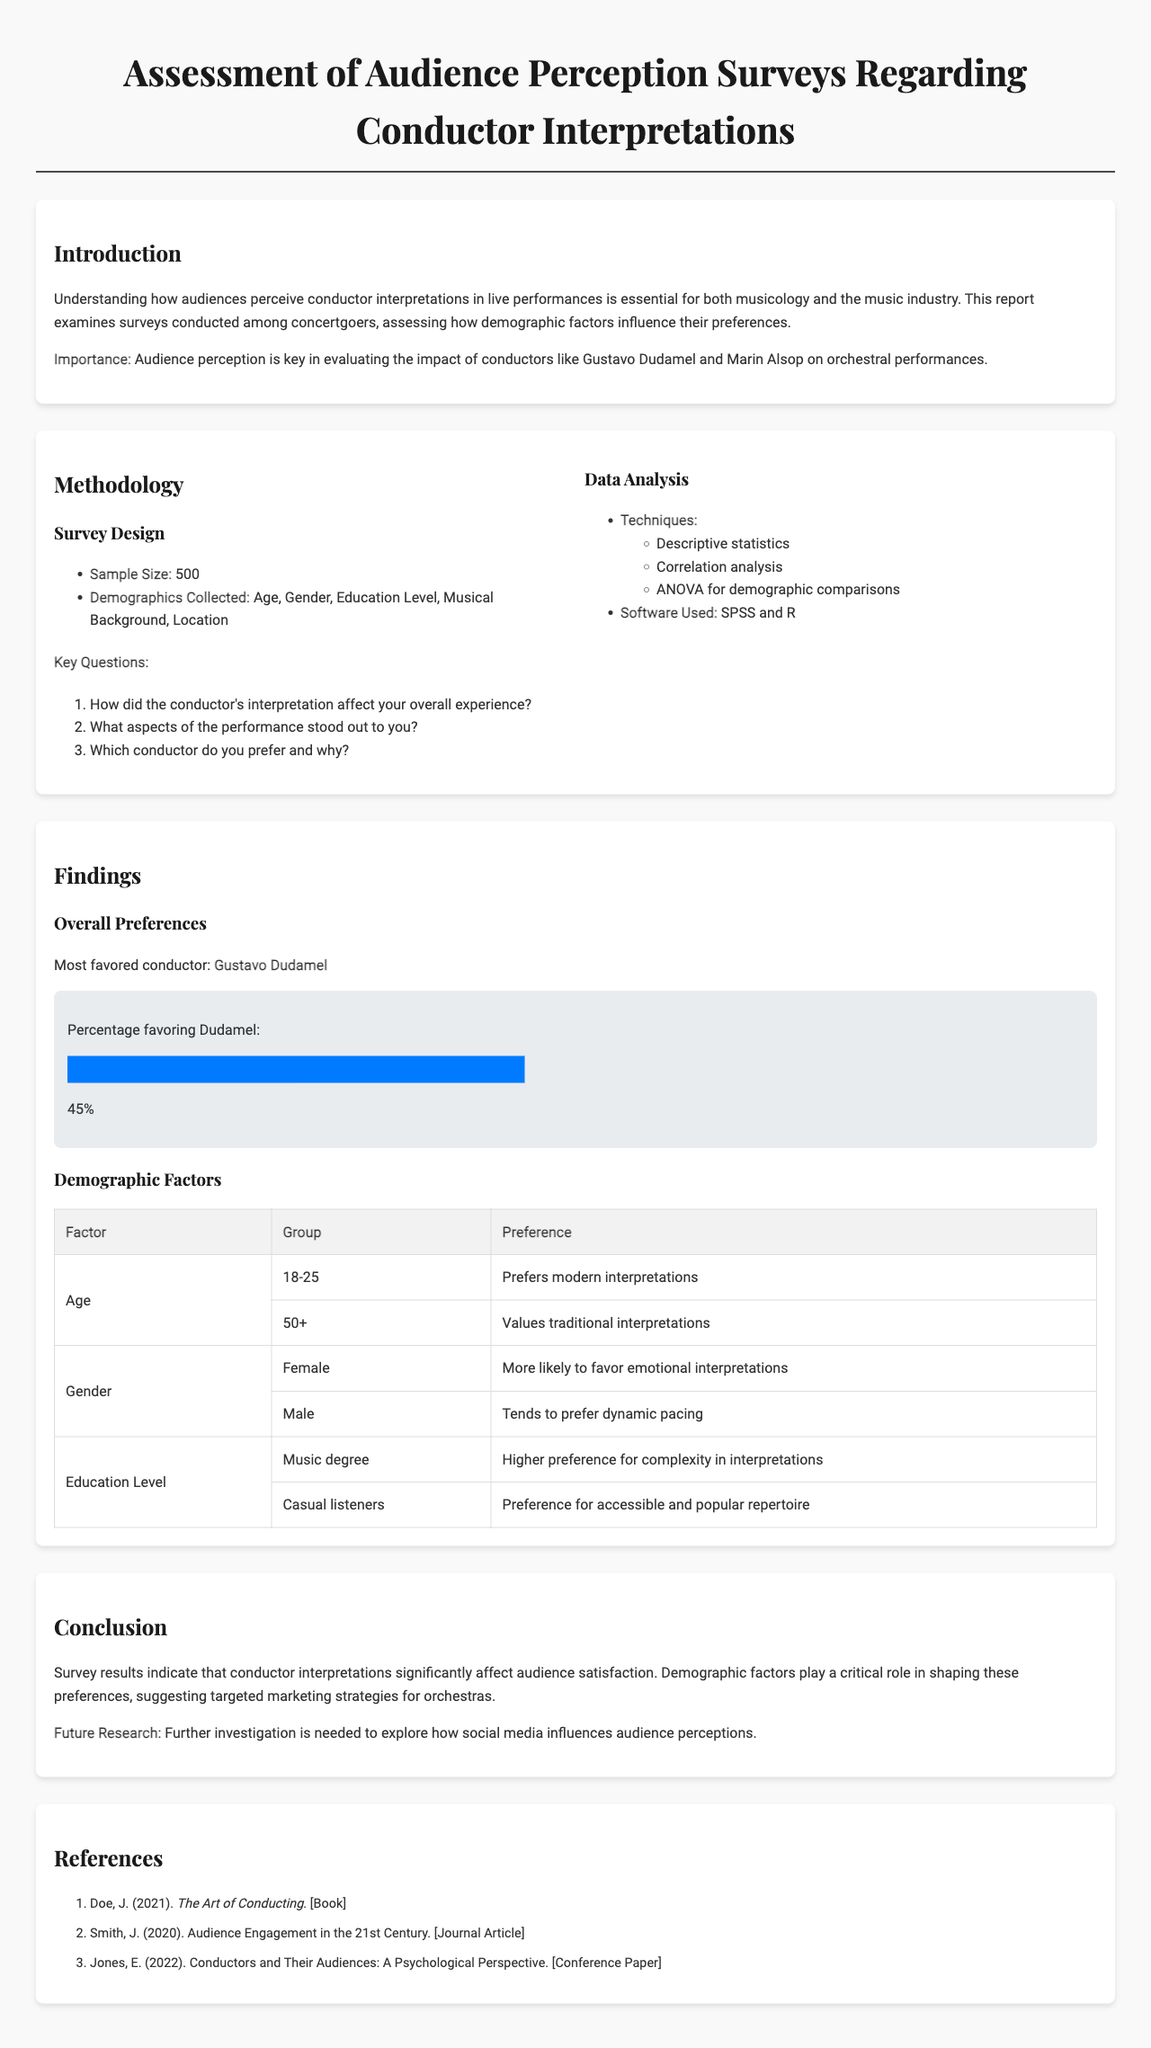What is the sample size of the survey? The sample size is mentioned in the methodology section as the total number of respondents to the survey.
Answer: 500 Who is the most favored conductor according to the findings? The findings highlight the conductor who received the highest preference from survey respondents.
Answer: Gustavo Dudamel What demographic factor values traditional interpretations? The findings include the different groups that were surveyed and their preferences concerning conductors.
Answer: Age (50+) Which gender is more likely to favor emotional interpretations? The document categorizes preferences by gender, indicating which gender tends to favor particular interpretative styles.
Answer: Female What analysis technique was used for demographic comparisons? The methodology section details the statistical techniques employed to assess the data, specifically for demographic analysis.
Answer: ANOVA What do casual listeners generally prefer? The table outlines the preferences of different education levels, detailing what casual listeners lean towards in performances.
Answer: Accessible and popular repertoire What is suggested for future research in the conclusion? The conclusion section discusses areas that need further investigation regarding audience perceptions and their influences.
Answer: Social media influences Which conductor do audiences prefer based on the analysis of age? The evidence gathered in the document suggests a preference that relates to age demographics and conductor interpretations.
Answer: Modern interpretations What is the main purpose of the surveys conducted? The introduction states the goal behind conducting these surveys concerning conductor interpretations and audience perceptions.
Answer: Assess audience perception 